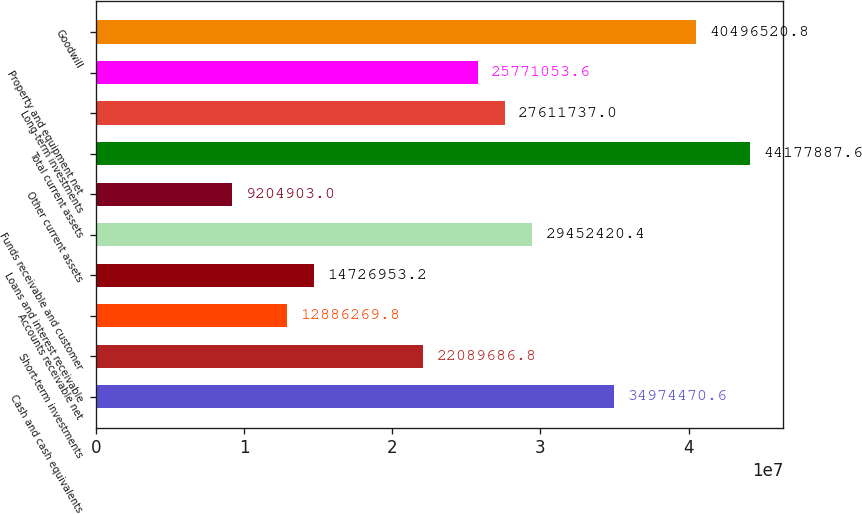Convert chart. <chart><loc_0><loc_0><loc_500><loc_500><bar_chart><fcel>Cash and cash equivalents<fcel>Short-term investments<fcel>Accounts receivable net<fcel>Loans and interest receivable<fcel>Funds receivable and customer<fcel>Other current assets<fcel>Total current assets<fcel>Long-term investments<fcel>Property and equipment net<fcel>Goodwill<nl><fcel>3.49745e+07<fcel>2.20897e+07<fcel>1.28863e+07<fcel>1.4727e+07<fcel>2.94524e+07<fcel>9.2049e+06<fcel>4.41779e+07<fcel>2.76117e+07<fcel>2.57711e+07<fcel>4.04965e+07<nl></chart> 